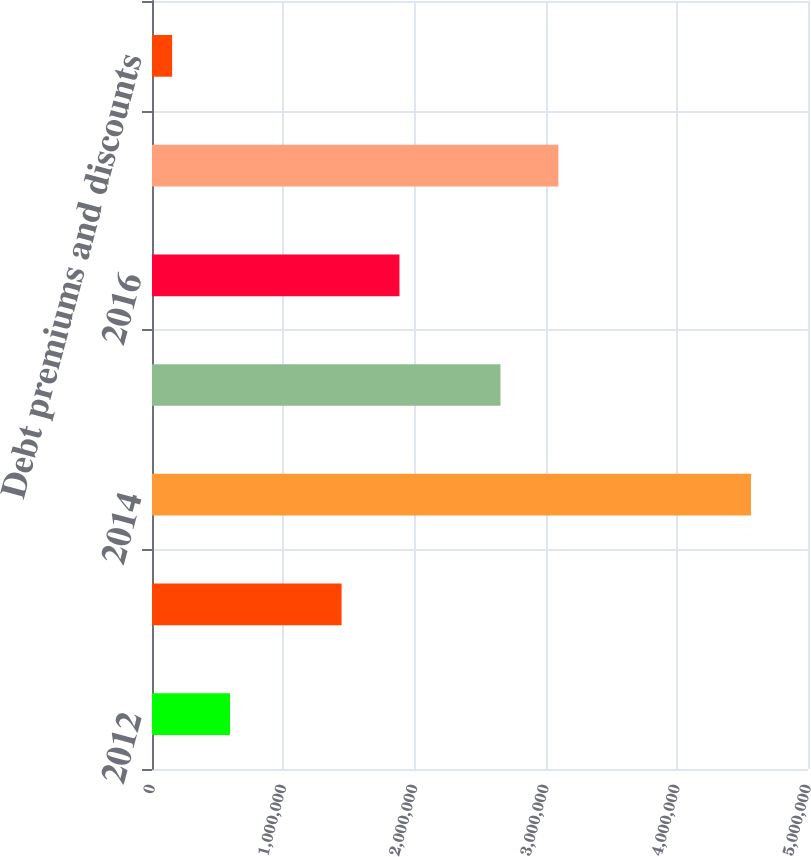<chart> <loc_0><loc_0><loc_500><loc_500><bar_chart><fcel>2012<fcel>2013<fcel>2014<fcel>2015<fcel>2016<fcel>Thereafter<fcel>Debt premiums and discounts<nl><fcel>594645<fcel>1.44507e+06<fcel>4.56549e+06<fcel>2.65639e+06<fcel>1.88628e+06<fcel>3.09759e+06<fcel>153440<nl></chart> 